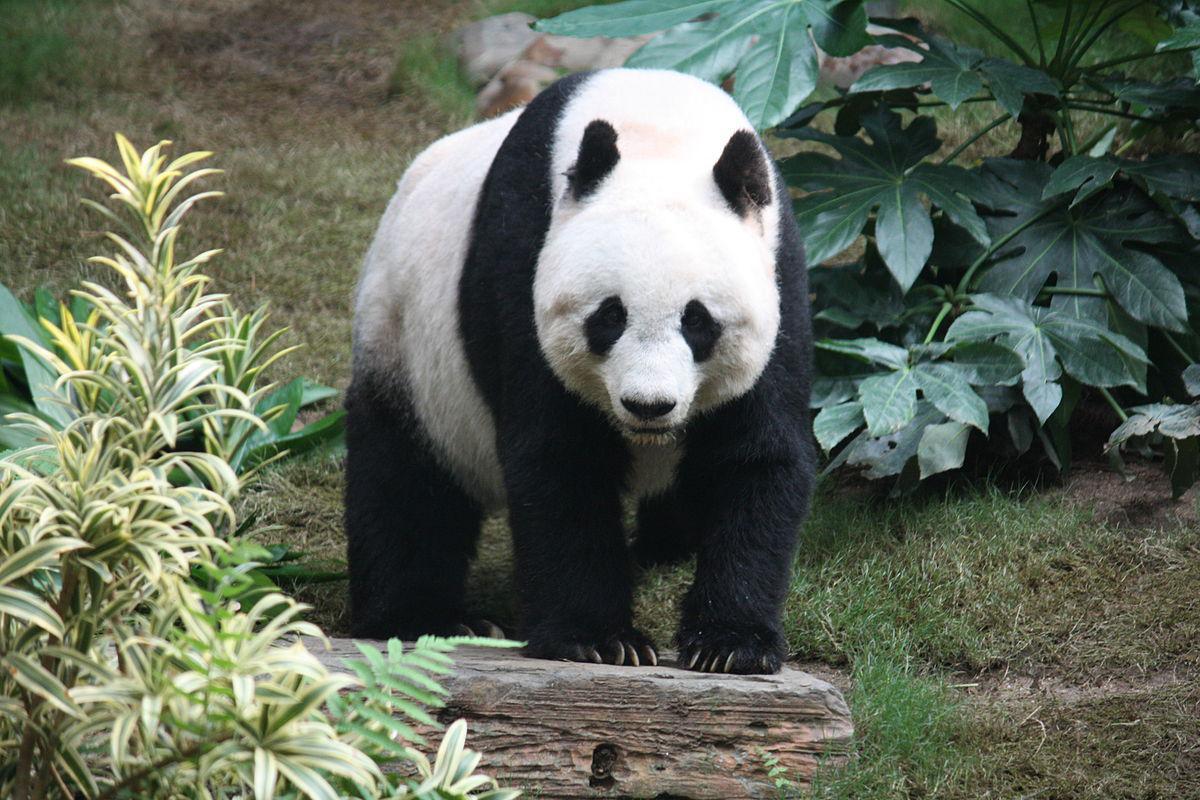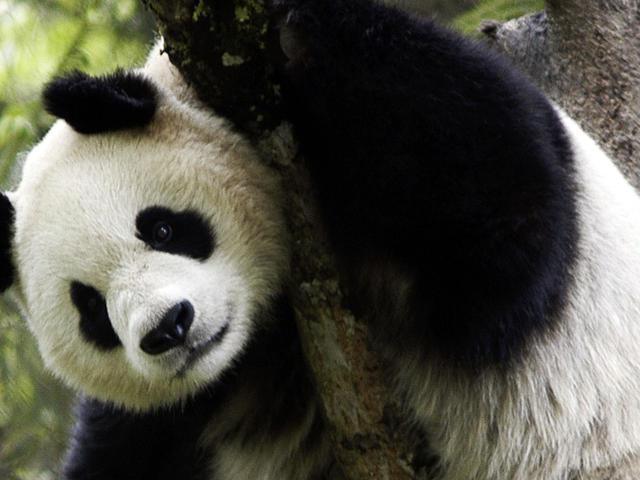The first image is the image on the left, the second image is the image on the right. Evaluate the accuracy of this statement regarding the images: "An image shows one camera-facing panda in a grassy area, standing with all four paws on a surface.". Is it true? Answer yes or no. Yes. 